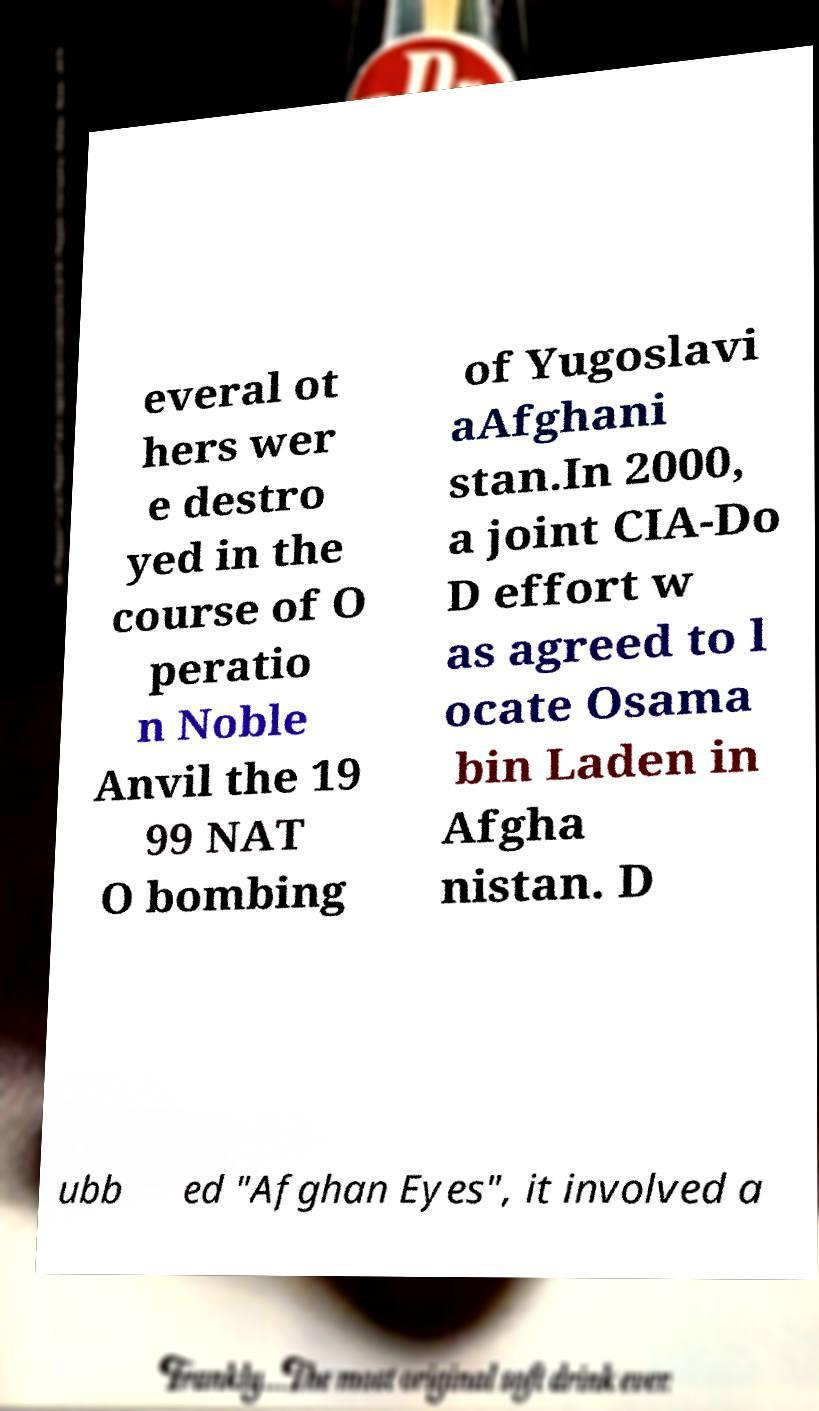Could you assist in decoding the text presented in this image and type it out clearly? everal ot hers wer e destro yed in the course of O peratio n Noble Anvil the 19 99 NAT O bombing of Yugoslavi aAfghani stan.In 2000, a joint CIA-Do D effort w as agreed to l ocate Osama bin Laden in Afgha nistan. D ubb ed "Afghan Eyes", it involved a 